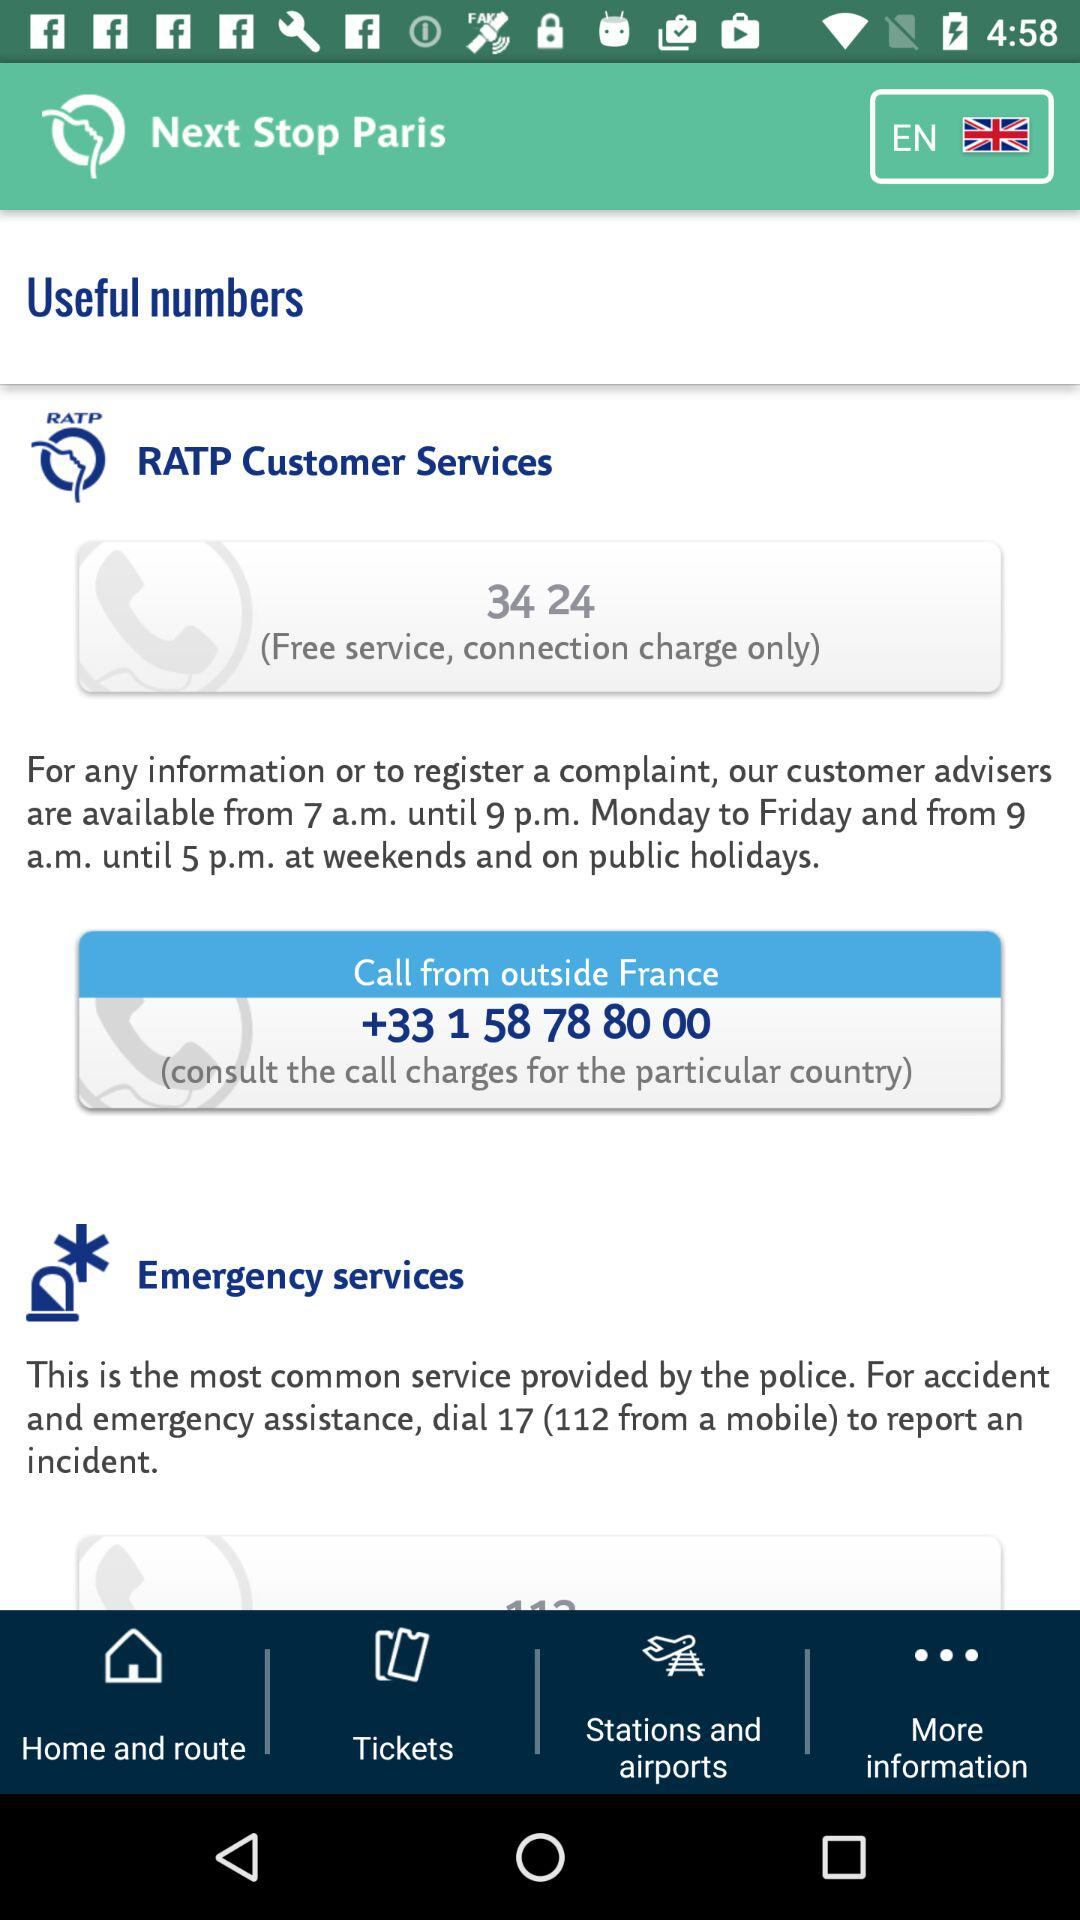How many numbers are available for emergency services?
Answer the question using a single word or phrase. 1 